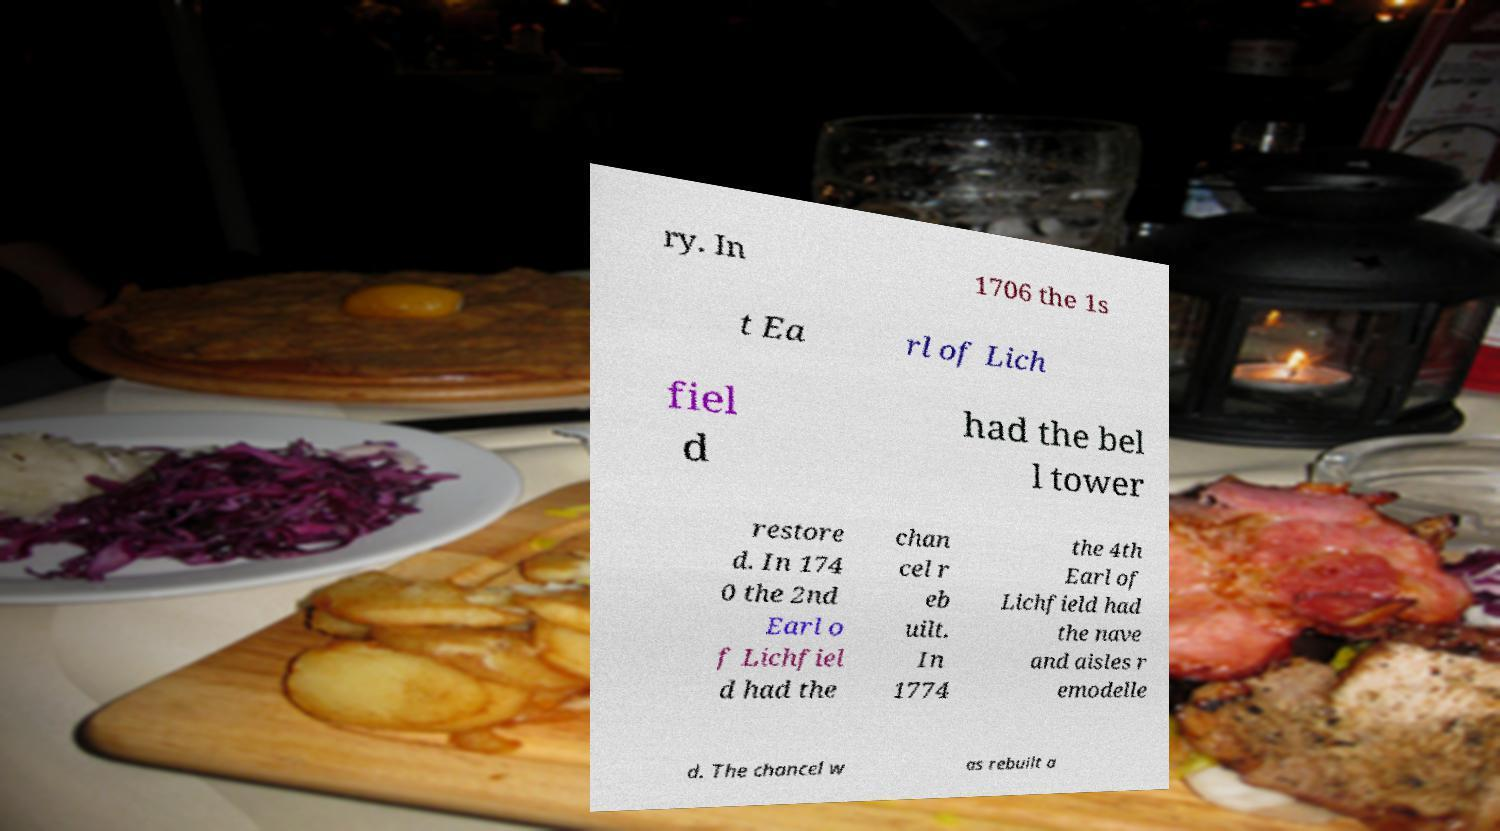For documentation purposes, I need the text within this image transcribed. Could you provide that? ry. In 1706 the 1s t Ea rl of Lich fiel d had the bel l tower restore d. In 174 0 the 2nd Earl o f Lichfiel d had the chan cel r eb uilt. In 1774 the 4th Earl of Lichfield had the nave and aisles r emodelle d. The chancel w as rebuilt a 